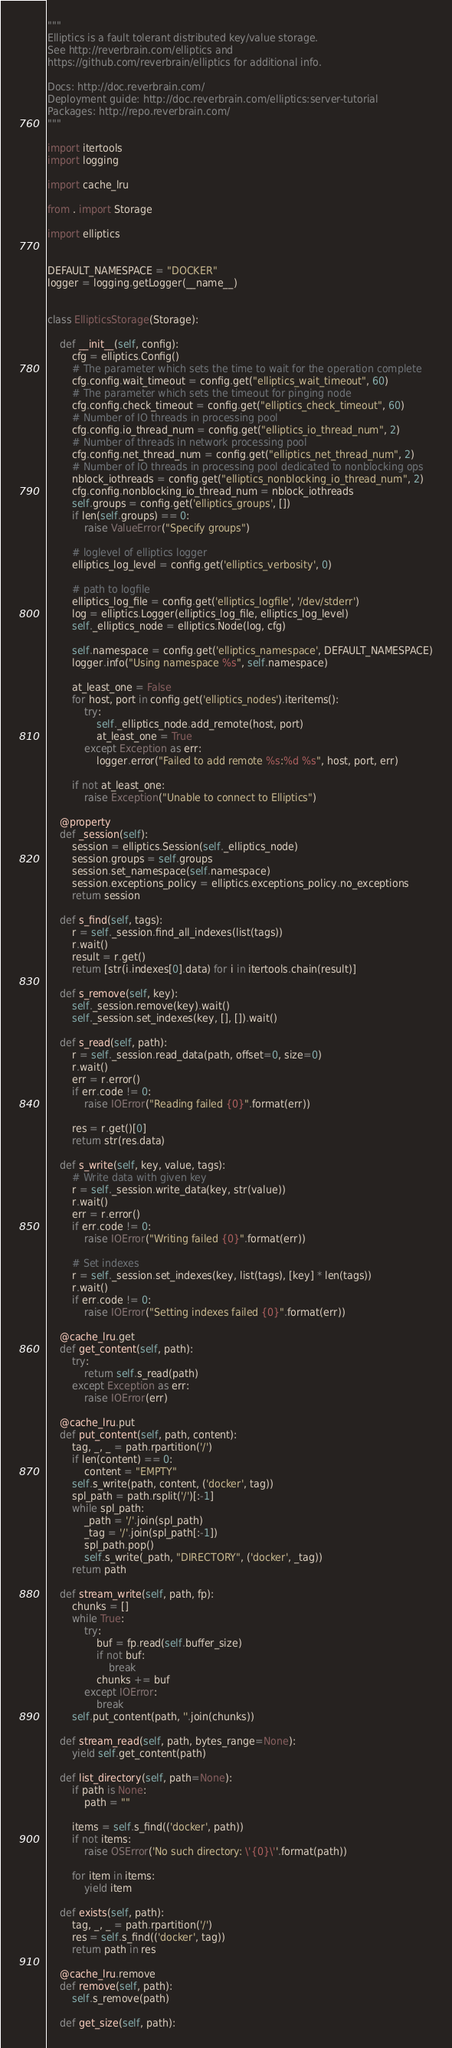<code> <loc_0><loc_0><loc_500><loc_500><_Python_>"""
Elliptics is a fault tolerant distributed key/value storage.
See http://reverbrain.com/elliptics and
https://github.com/reverbrain/elliptics for additional info.

Docs: http://doc.reverbrain.com/
Deployment guide: http://doc.reverbrain.com/elliptics:server-tutorial
Packages: http://repo.reverbrain.com/
"""

import itertools
import logging

import cache_lru

from . import Storage

import elliptics


DEFAULT_NAMESPACE = "DOCKER"
logger = logging.getLogger(__name__)


class EllipticsStorage(Storage):

    def __init__(self, config):
        cfg = elliptics.Config()
        # The parameter which sets the time to wait for the operation complete
        cfg.config.wait_timeout = config.get("elliptics_wait_timeout", 60)
        # The parameter which sets the timeout for pinging node
        cfg.config.check_timeout = config.get("elliptics_check_timeout", 60)
        # Number of IO threads in processing pool
        cfg.config.io_thread_num = config.get("elliptics_io_thread_num", 2)
        # Number of threads in network processing pool
        cfg.config.net_thread_num = config.get("elliptics_net_thread_num", 2)
        # Number of IO threads in processing pool dedicated to nonblocking ops
        nblock_iothreads = config.get("elliptics_nonblocking_io_thread_num", 2)
        cfg.config.nonblocking_io_thread_num = nblock_iothreads
        self.groups = config.get('elliptics_groups', [])
        if len(self.groups) == 0:
            raise ValueError("Specify groups")

        # loglevel of elliptics logger
        elliptics_log_level = config.get('elliptics_verbosity', 0)

        # path to logfile
        elliptics_log_file = config.get('elliptics_logfile', '/dev/stderr')
        log = elliptics.Logger(elliptics_log_file, elliptics_log_level)
        self._elliptics_node = elliptics.Node(log, cfg)

        self.namespace = config.get('elliptics_namespace', DEFAULT_NAMESPACE)
        logger.info("Using namespace %s", self.namespace)

        at_least_one = False
        for host, port in config.get('elliptics_nodes').iteritems():
            try:
                self._elliptics_node.add_remote(host, port)
                at_least_one = True
            except Exception as err:
                logger.error("Failed to add remote %s:%d %s", host, port, err)

        if not at_least_one:
            raise Exception("Unable to connect to Elliptics")

    @property
    def _session(self):
        session = elliptics.Session(self._elliptics_node)
        session.groups = self.groups
        session.set_namespace(self.namespace)
        session.exceptions_policy = elliptics.exceptions_policy.no_exceptions
        return session

    def s_find(self, tags):
        r = self._session.find_all_indexes(list(tags))
        r.wait()
        result = r.get()
        return [str(i.indexes[0].data) for i in itertools.chain(result)]

    def s_remove(self, key):
        self._session.remove(key).wait()
        self._session.set_indexes(key, [], []).wait()

    def s_read(self, path):
        r = self._session.read_data(path, offset=0, size=0)
        r.wait()
        err = r.error()
        if err.code != 0:
            raise IOError("Reading failed {0}".format(err))

        res = r.get()[0]
        return str(res.data)

    def s_write(self, key, value, tags):
        # Write data with given key
        r = self._session.write_data(key, str(value))
        r.wait()
        err = r.error()
        if err.code != 0:
            raise IOError("Writing failed {0}".format(err))

        # Set indexes
        r = self._session.set_indexes(key, list(tags), [key] * len(tags))
        r.wait()
        if err.code != 0:
            raise IOError("Setting indexes failed {0}".format(err))

    @cache_lru.get
    def get_content(self, path):
        try:
            return self.s_read(path)
        except Exception as err:
            raise IOError(err)

    @cache_lru.put
    def put_content(self, path, content):
        tag, _, _ = path.rpartition('/')
        if len(content) == 0:
            content = "EMPTY"
        self.s_write(path, content, ('docker', tag))
        spl_path = path.rsplit('/')[:-1]
        while spl_path:
            _path = '/'.join(spl_path)
            _tag = '/'.join(spl_path[:-1])
            spl_path.pop()
            self.s_write(_path, "DIRECTORY", ('docker', _tag))
        return path

    def stream_write(self, path, fp):
        chunks = []
        while True:
            try:
                buf = fp.read(self.buffer_size)
                if not buf:
                    break
                chunks += buf
            except IOError:
                break
        self.put_content(path, ''.join(chunks))

    def stream_read(self, path, bytes_range=None):
        yield self.get_content(path)

    def list_directory(self, path=None):
        if path is None:
            path = ""

        items = self.s_find(('docker', path))
        if not items:
            raise OSError('No such directory: \'{0}\''.format(path))

        for item in items:
            yield item

    def exists(self, path):
        tag, _, _ = path.rpartition('/')
        res = self.s_find(('docker', tag))
        return path in res

    @cache_lru.remove
    def remove(self, path):
        self.s_remove(path)

    def get_size(self, path):</code> 